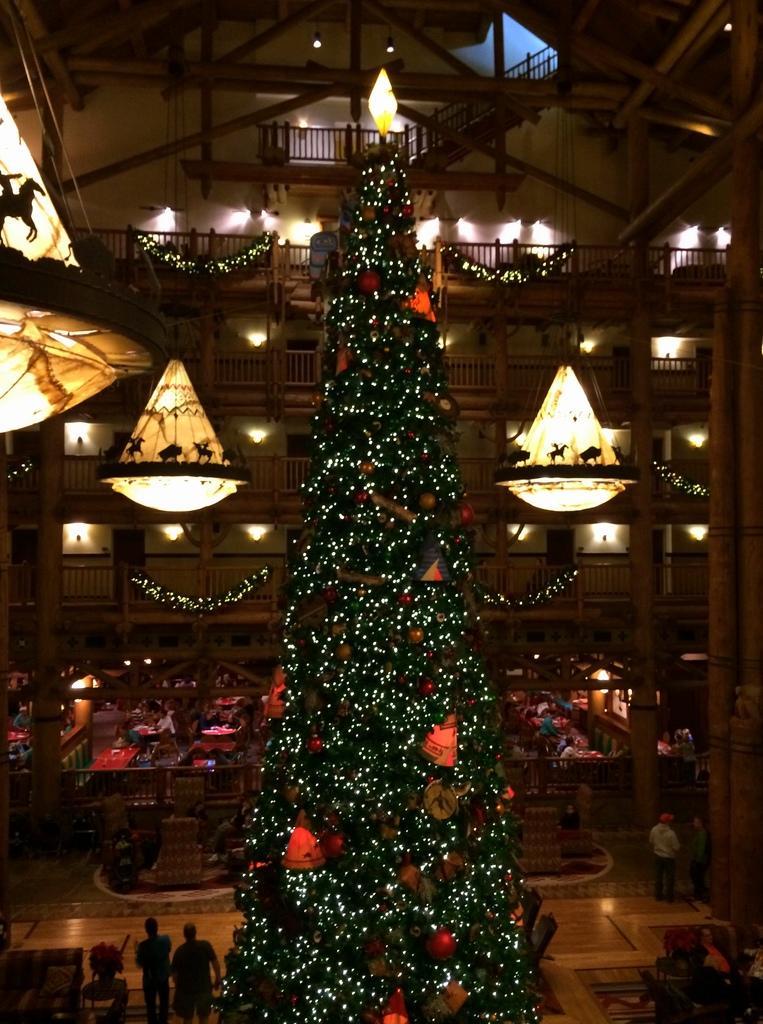Can you describe this image briefly? This is the picture of a building. In this picture there is a Christmas tree in the foreground and there are lights and there are objects on the tree. At the back there are lights. At the bottom there are group of people, few people are sitting and few people are standing. At the bottom there are tables and chairs. 